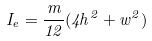<formula> <loc_0><loc_0><loc_500><loc_500>I _ { e } = \frac { m } { 1 2 } ( 4 h ^ { 2 } + w ^ { 2 } )</formula> 